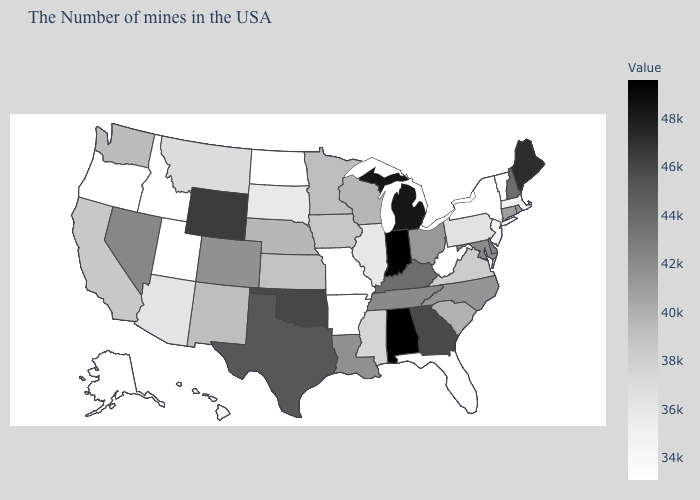Which states have the lowest value in the USA?
Be succinct. Vermont, New York, West Virginia, Florida, Missouri, Arkansas, North Dakota, Utah, Idaho, Oregon, Alaska. Does Indiana have the lowest value in the MidWest?
Short answer required. No. Is the legend a continuous bar?
Give a very brief answer. Yes. 